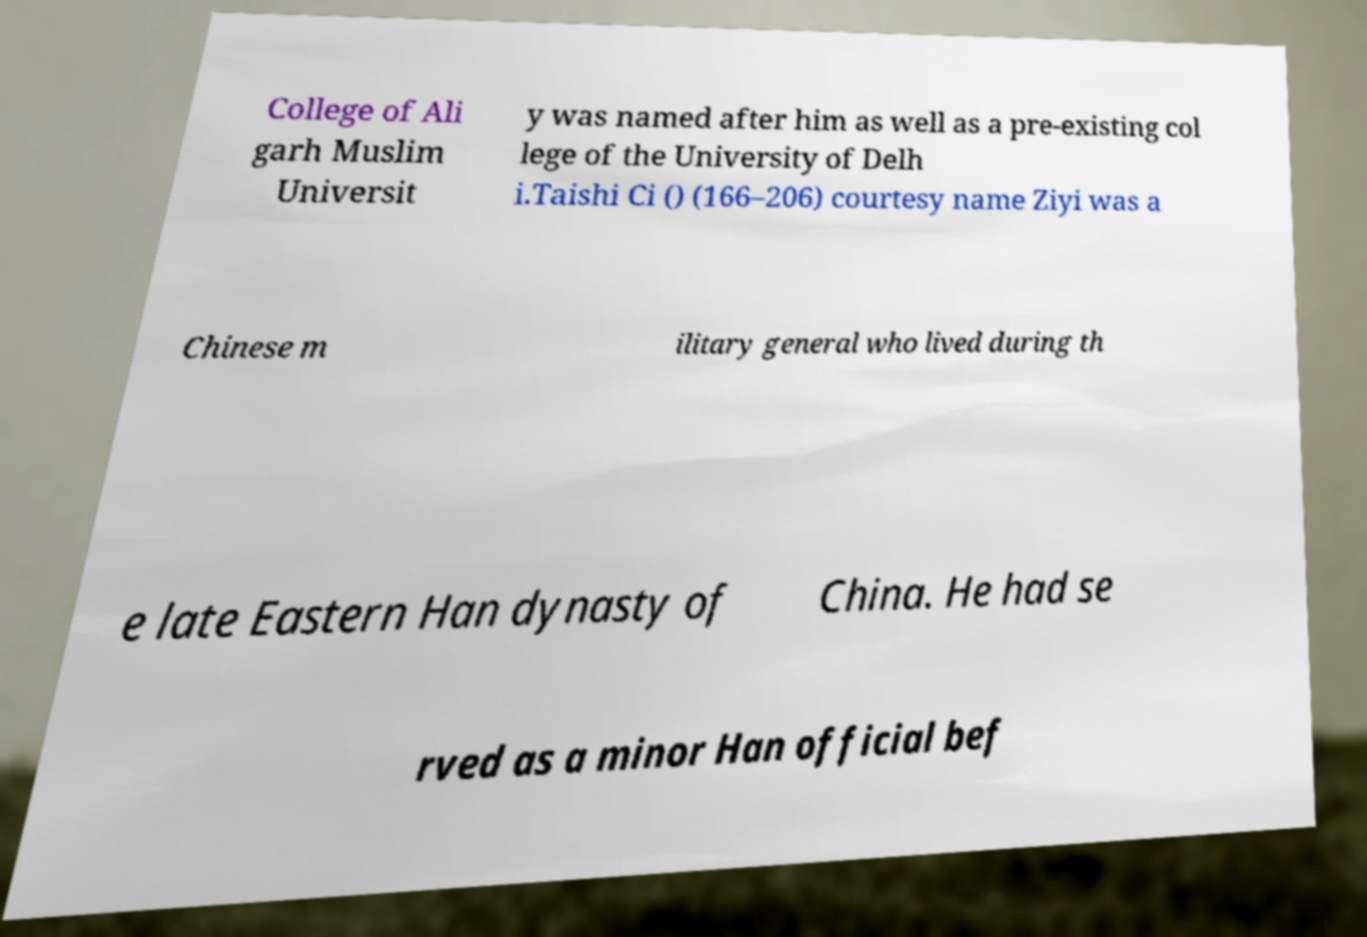Could you extract and type out the text from this image? College of Ali garh Muslim Universit y was named after him as well as a pre-existing col lege of the University of Delh i.Taishi Ci () (166–206) courtesy name Ziyi was a Chinese m ilitary general who lived during th e late Eastern Han dynasty of China. He had se rved as a minor Han official bef 